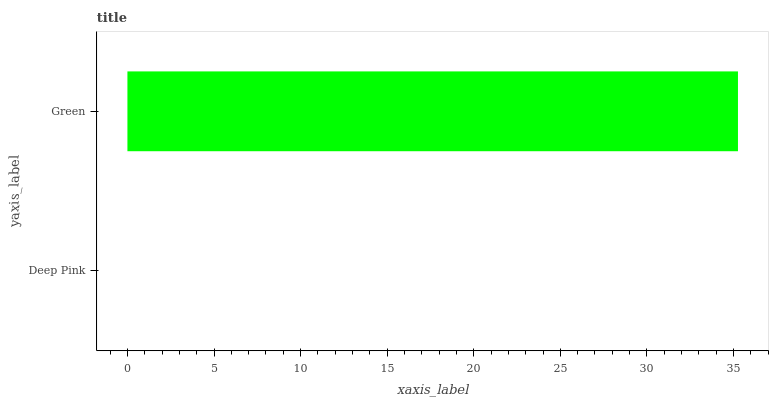Is Deep Pink the minimum?
Answer yes or no. Yes. Is Green the maximum?
Answer yes or no. Yes. Is Green the minimum?
Answer yes or no. No. Is Green greater than Deep Pink?
Answer yes or no. Yes. Is Deep Pink less than Green?
Answer yes or no. Yes. Is Deep Pink greater than Green?
Answer yes or no. No. Is Green less than Deep Pink?
Answer yes or no. No. Is Green the high median?
Answer yes or no. Yes. Is Deep Pink the low median?
Answer yes or no. Yes. Is Deep Pink the high median?
Answer yes or no. No. Is Green the low median?
Answer yes or no. No. 